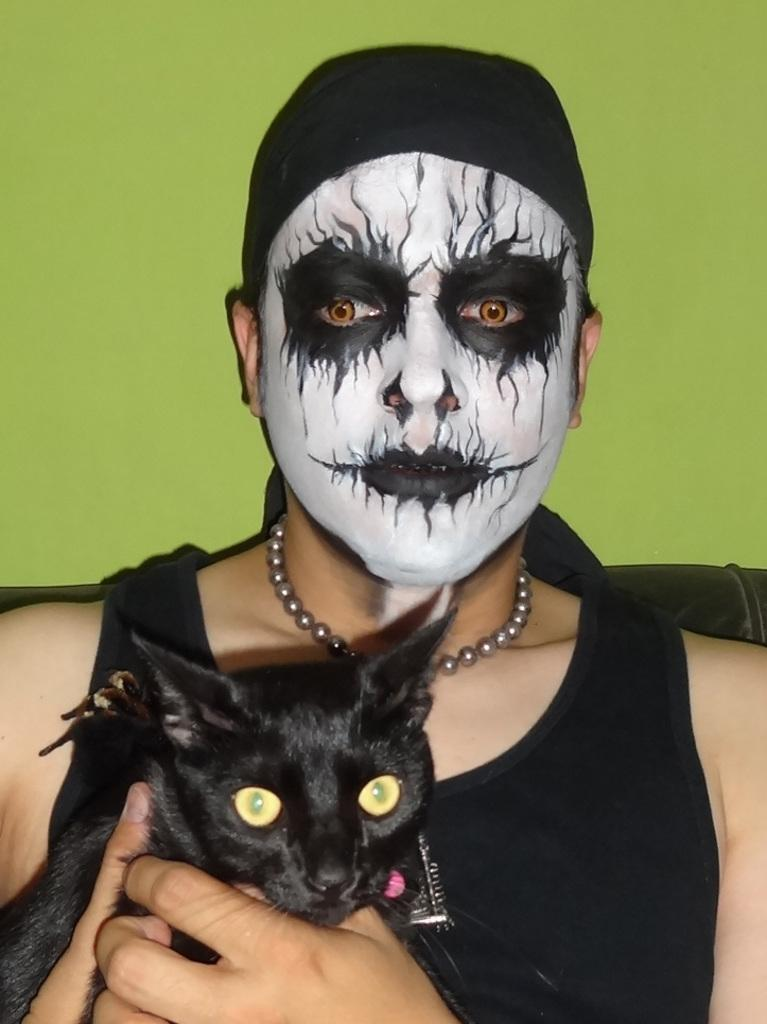Who or what is the main subject in the image? There is a person in the image. What is the person wearing that stands out? The person is wearing a different costume. What color is the vest the person is wearing? The person is wearing a black color vest. What is the person holding in their hands? The person is holding a black color cat in their hands. What can be seen in the background of the image? There is a wall in the background of the image. What color is the wall in the background? The wall is in green color. Is there any sugar visible in the image? There is no mention of sugar in the provided facts, so it cannot be determined if sugar is visible in the image. 